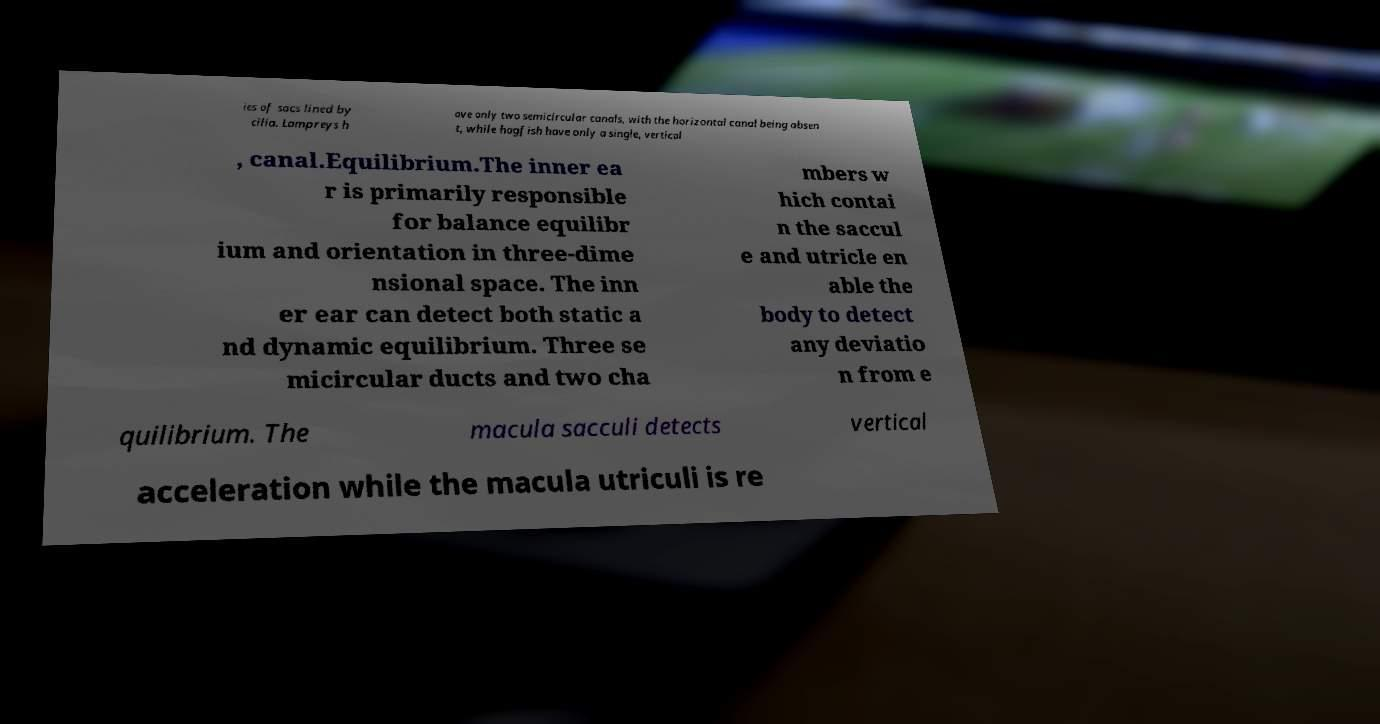Please read and relay the text visible in this image. What does it say? ies of sacs lined by cilia. Lampreys h ave only two semicircular canals, with the horizontal canal being absen t, while hagfish have only a single, vertical , canal.Equilibrium.The inner ea r is primarily responsible for balance equilibr ium and orientation in three-dime nsional space. The inn er ear can detect both static a nd dynamic equilibrium. Three se micircular ducts and two cha mbers w hich contai n the saccul e and utricle en able the body to detect any deviatio n from e quilibrium. The macula sacculi detects vertical acceleration while the macula utriculi is re 